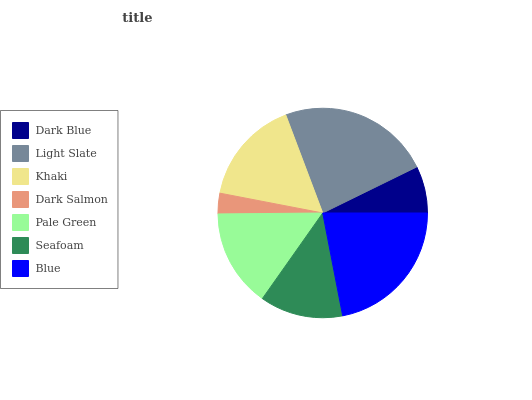Is Dark Salmon the minimum?
Answer yes or no. Yes. Is Light Slate the maximum?
Answer yes or no. Yes. Is Khaki the minimum?
Answer yes or no. No. Is Khaki the maximum?
Answer yes or no. No. Is Light Slate greater than Khaki?
Answer yes or no. Yes. Is Khaki less than Light Slate?
Answer yes or no. Yes. Is Khaki greater than Light Slate?
Answer yes or no. No. Is Light Slate less than Khaki?
Answer yes or no. No. Is Pale Green the high median?
Answer yes or no. Yes. Is Pale Green the low median?
Answer yes or no. Yes. Is Khaki the high median?
Answer yes or no. No. Is Dark Salmon the low median?
Answer yes or no. No. 